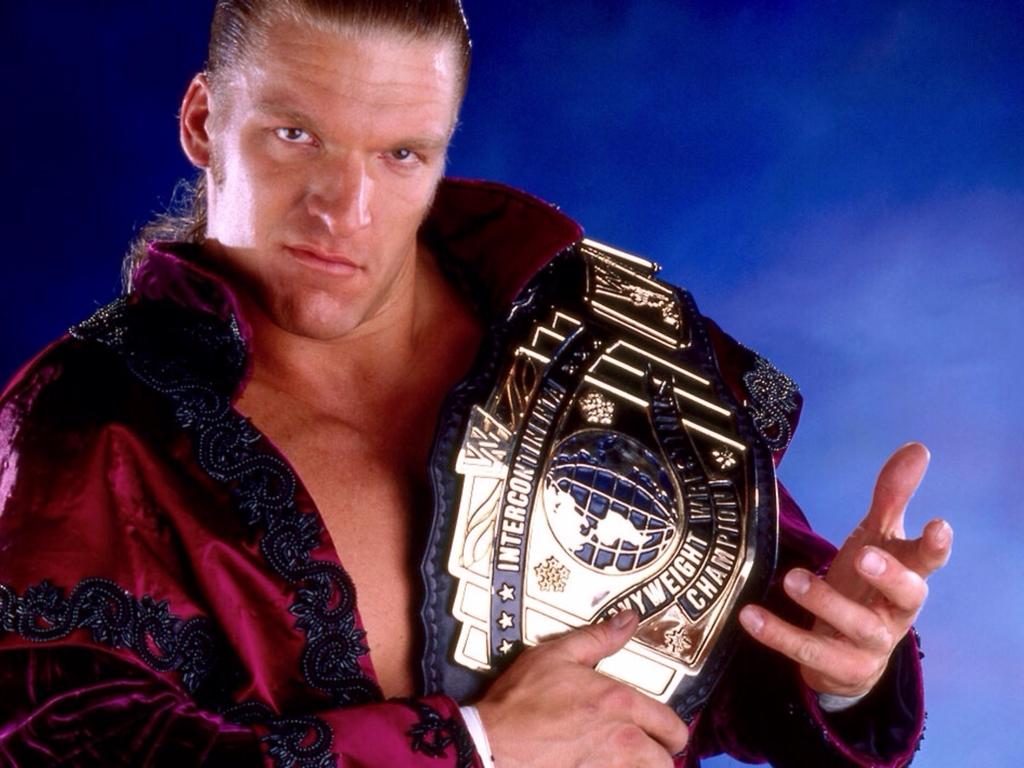What weight class is this man a champion of?
Ensure brevity in your answer.  Heavyweight. What does the first word say?
Give a very brief answer. Intercontinental. 